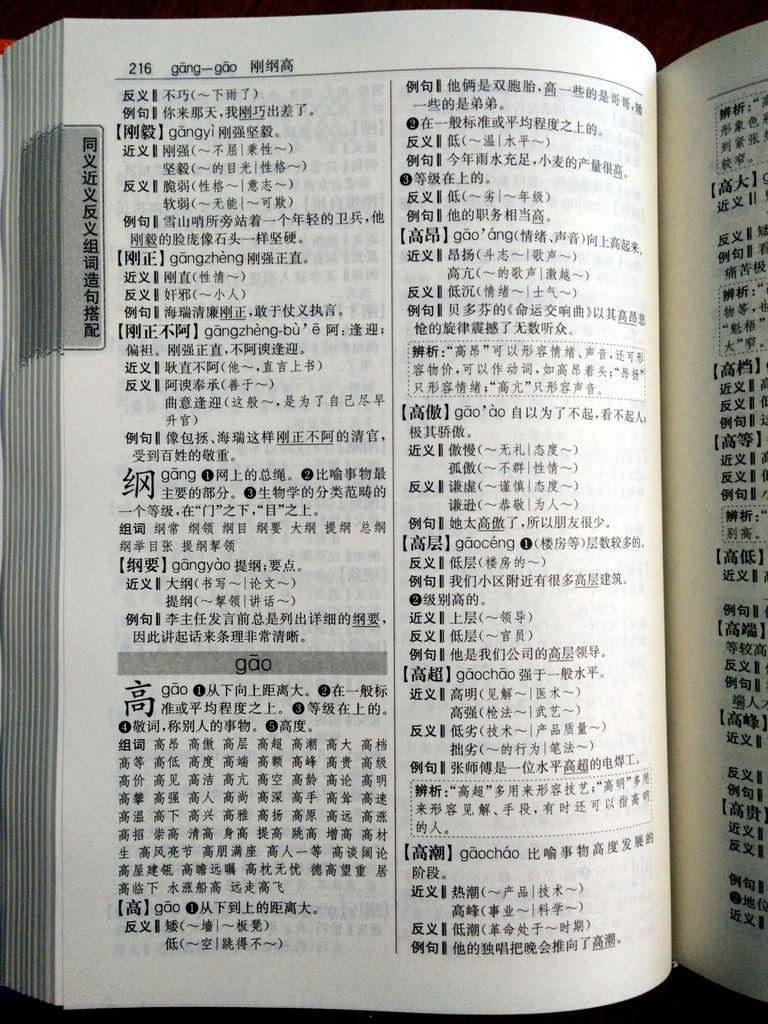<image>
Describe the image concisely. Book with Chinese words and symbols including  Gangzheng and gao 